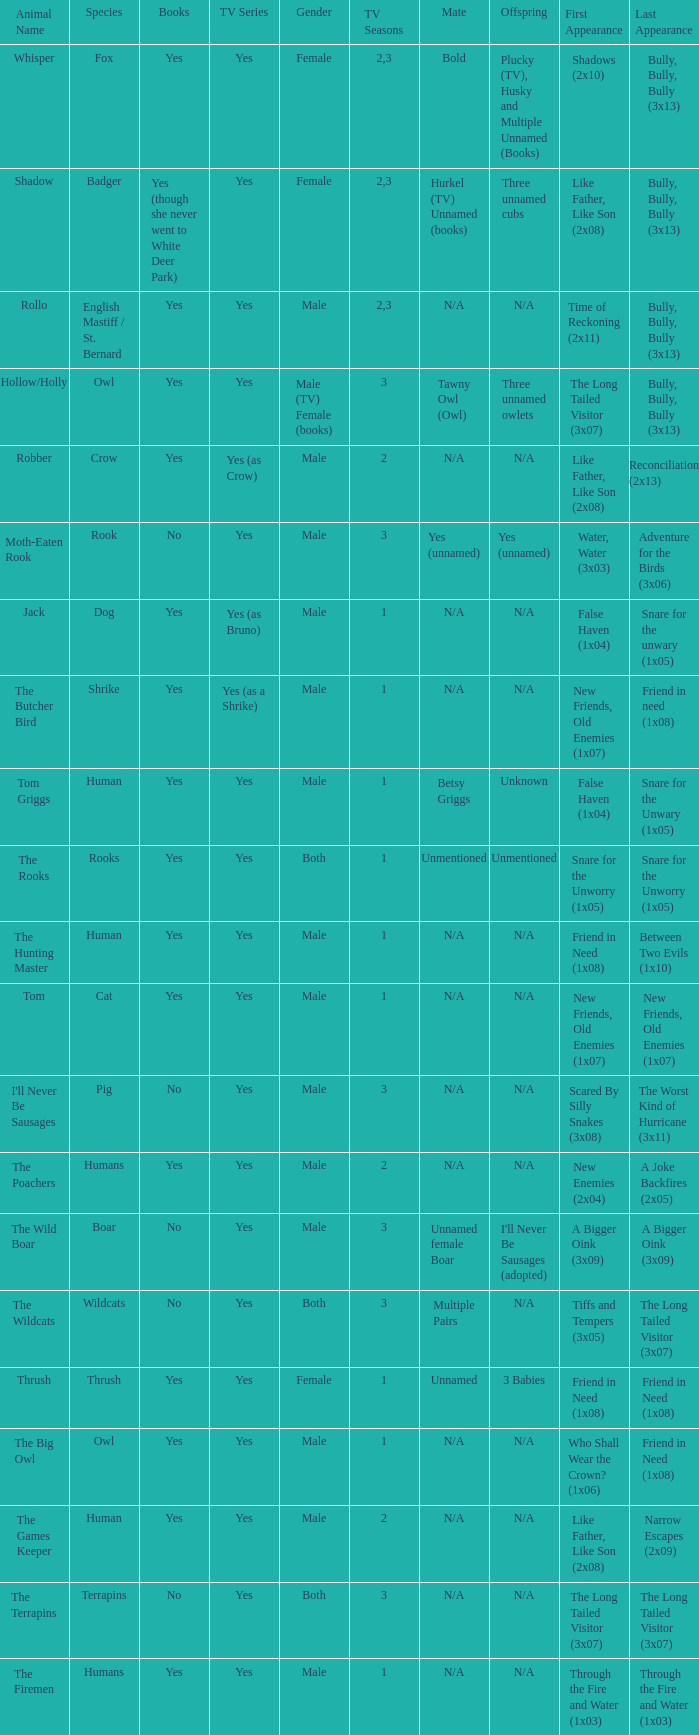What series includes a boar? Yes. 